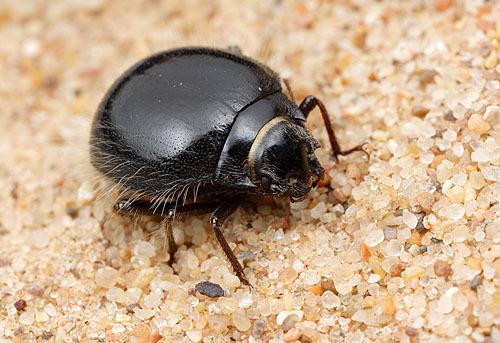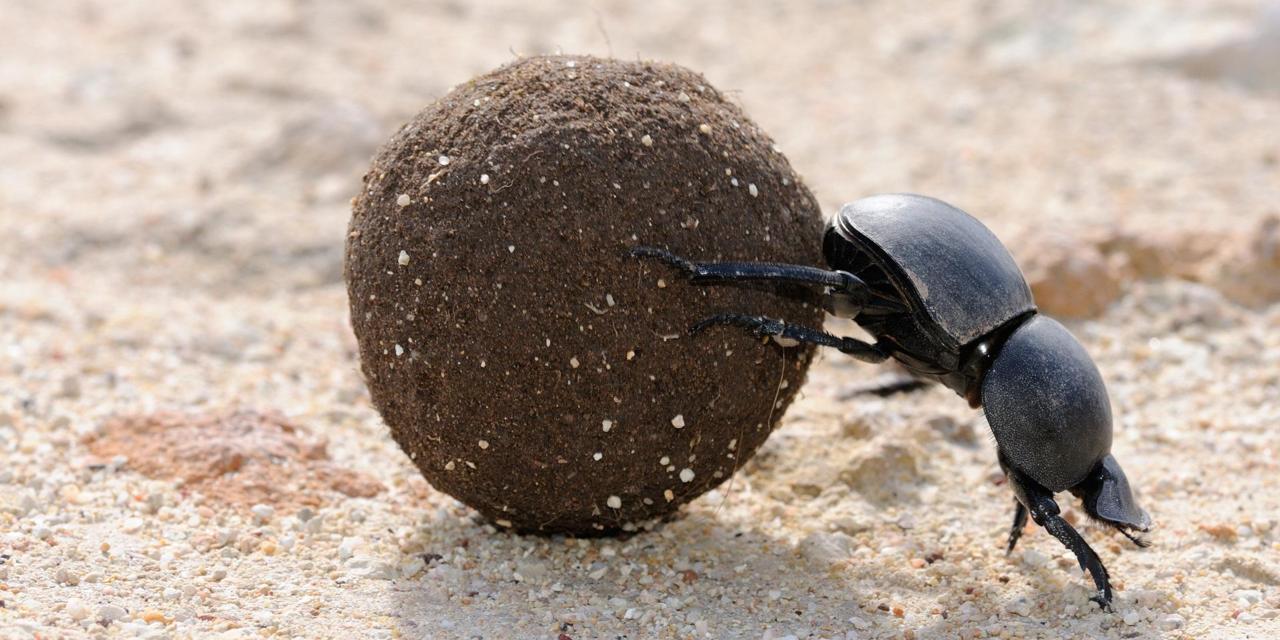The first image is the image on the left, the second image is the image on the right. Evaluate the accuracy of this statement regarding the images: "An image includes one dung ball and two beetles.". Is it true? Answer yes or no. No. The first image is the image on the left, the second image is the image on the right. Assess this claim about the two images: "There are 3 beetles present near a dung ball.". Correct or not? Answer yes or no. No. 